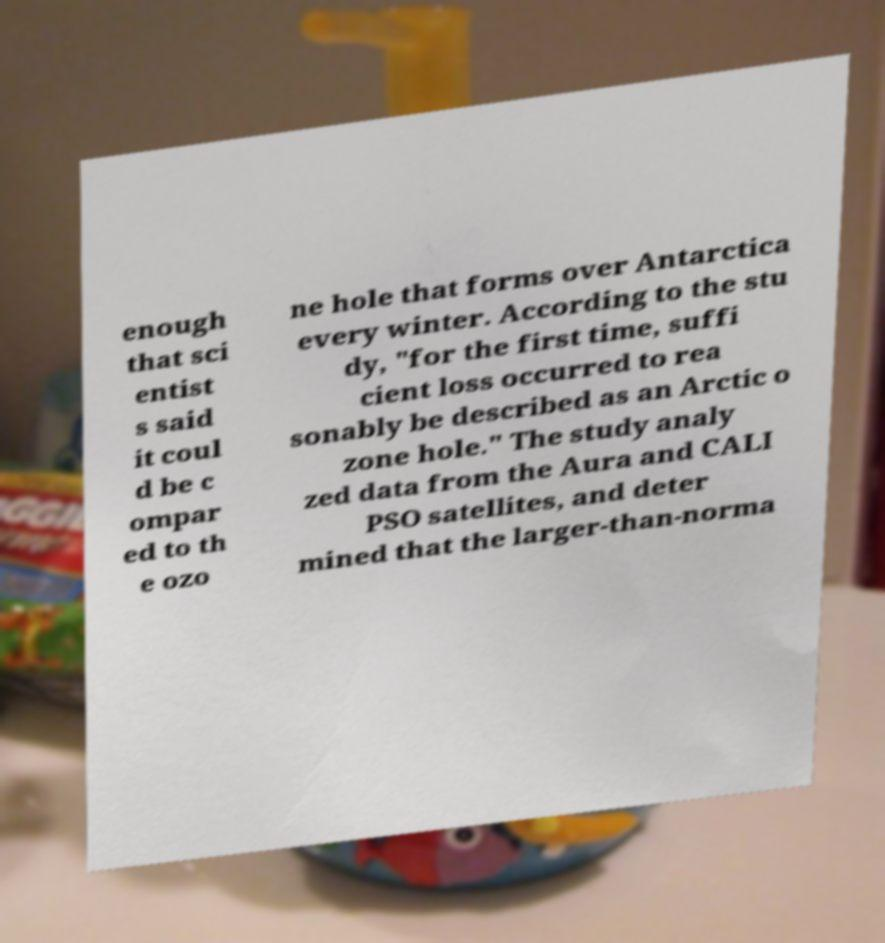Can you accurately transcribe the text from the provided image for me? enough that sci entist s said it coul d be c ompar ed to th e ozo ne hole that forms over Antarctica every winter. According to the stu dy, "for the first time, suffi cient loss occurred to rea sonably be described as an Arctic o zone hole." The study analy zed data from the Aura and CALI PSO satellites, and deter mined that the larger-than-norma 